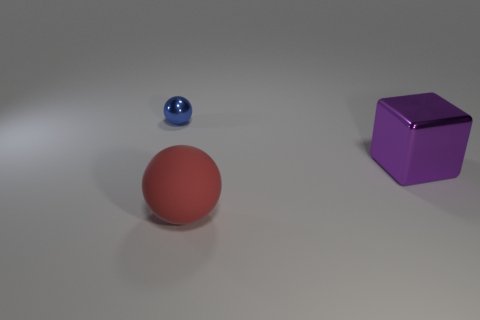Add 3 large red metal things. How many objects exist? 6 Subtract all spheres. How many objects are left? 1 Subtract 2 balls. How many balls are left? 0 Subtract all blue balls. How many balls are left? 1 Add 3 blue spheres. How many blue spheres are left? 4 Add 1 big red objects. How many big red objects exist? 2 Subtract 0 red cylinders. How many objects are left? 3 Subtract all blue spheres. Subtract all green blocks. How many spheres are left? 1 Subtract all blue cylinders. How many green blocks are left? 0 Subtract all large purple metal things. Subtract all large red spheres. How many objects are left? 1 